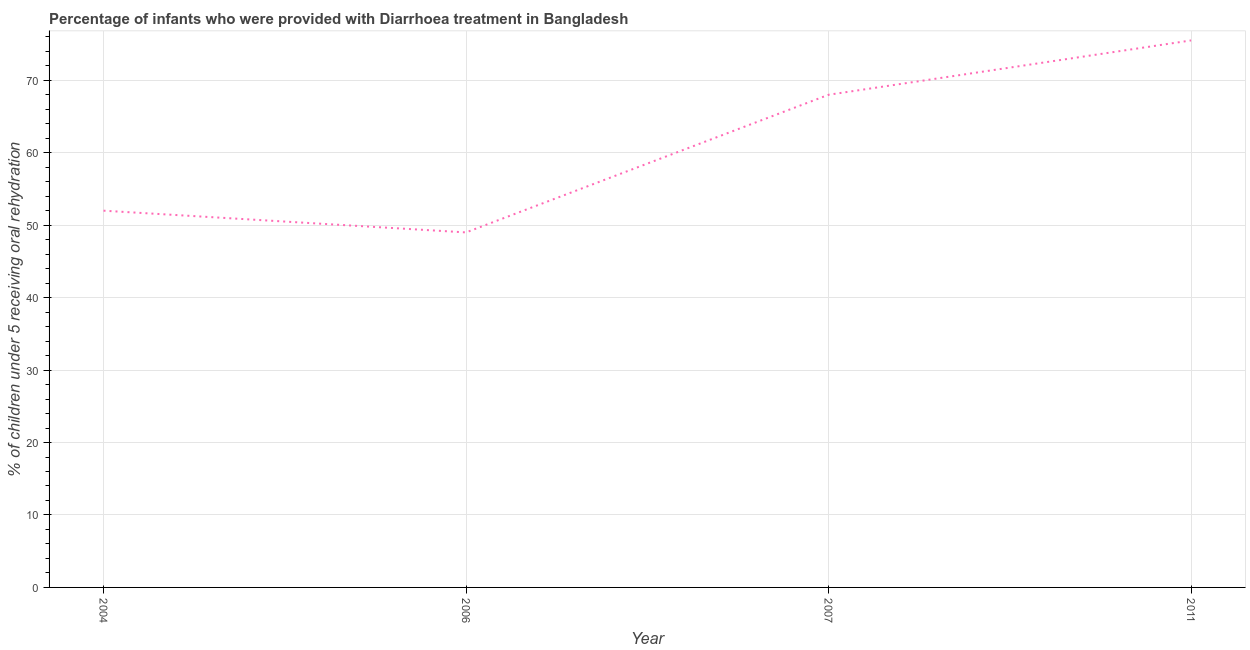Across all years, what is the maximum percentage of children who were provided with treatment diarrhoea?
Keep it short and to the point. 75.5. In which year was the percentage of children who were provided with treatment diarrhoea maximum?
Your answer should be very brief. 2011. In which year was the percentage of children who were provided with treatment diarrhoea minimum?
Give a very brief answer. 2006. What is the sum of the percentage of children who were provided with treatment diarrhoea?
Offer a very short reply. 244.5. What is the difference between the percentage of children who were provided with treatment diarrhoea in 2006 and 2011?
Provide a short and direct response. -26.5. What is the average percentage of children who were provided with treatment diarrhoea per year?
Ensure brevity in your answer.  61.12. What is the ratio of the percentage of children who were provided with treatment diarrhoea in 2006 to that in 2007?
Your answer should be compact. 0.72. Is the percentage of children who were provided with treatment diarrhoea in 2004 less than that in 2007?
Your answer should be very brief. Yes. Is the difference between the percentage of children who were provided with treatment diarrhoea in 2006 and 2011 greater than the difference between any two years?
Your answer should be very brief. Yes. What is the difference between the highest and the second highest percentage of children who were provided with treatment diarrhoea?
Provide a succinct answer. 7.5. Is the sum of the percentage of children who were provided with treatment diarrhoea in 2004 and 2011 greater than the maximum percentage of children who were provided with treatment diarrhoea across all years?
Your answer should be very brief. Yes. What is the difference between the highest and the lowest percentage of children who were provided with treatment diarrhoea?
Offer a very short reply. 26.5. Does the percentage of children who were provided with treatment diarrhoea monotonically increase over the years?
Provide a succinct answer. No. How many years are there in the graph?
Make the answer very short. 4. Does the graph contain grids?
Make the answer very short. Yes. What is the title of the graph?
Offer a terse response. Percentage of infants who were provided with Diarrhoea treatment in Bangladesh. What is the label or title of the Y-axis?
Make the answer very short. % of children under 5 receiving oral rehydration. What is the % of children under 5 receiving oral rehydration of 2004?
Your response must be concise. 52. What is the % of children under 5 receiving oral rehydration in 2006?
Your answer should be very brief. 49. What is the % of children under 5 receiving oral rehydration of 2007?
Give a very brief answer. 68. What is the % of children under 5 receiving oral rehydration in 2011?
Give a very brief answer. 75.5. What is the difference between the % of children under 5 receiving oral rehydration in 2004 and 2006?
Your answer should be compact. 3. What is the difference between the % of children under 5 receiving oral rehydration in 2004 and 2007?
Make the answer very short. -16. What is the difference between the % of children under 5 receiving oral rehydration in 2004 and 2011?
Offer a very short reply. -23.5. What is the difference between the % of children under 5 receiving oral rehydration in 2006 and 2011?
Your answer should be compact. -26.5. What is the difference between the % of children under 5 receiving oral rehydration in 2007 and 2011?
Keep it short and to the point. -7.5. What is the ratio of the % of children under 5 receiving oral rehydration in 2004 to that in 2006?
Provide a succinct answer. 1.06. What is the ratio of the % of children under 5 receiving oral rehydration in 2004 to that in 2007?
Provide a short and direct response. 0.77. What is the ratio of the % of children under 5 receiving oral rehydration in 2004 to that in 2011?
Give a very brief answer. 0.69. What is the ratio of the % of children under 5 receiving oral rehydration in 2006 to that in 2007?
Make the answer very short. 0.72. What is the ratio of the % of children under 5 receiving oral rehydration in 2006 to that in 2011?
Provide a succinct answer. 0.65. What is the ratio of the % of children under 5 receiving oral rehydration in 2007 to that in 2011?
Give a very brief answer. 0.9. 